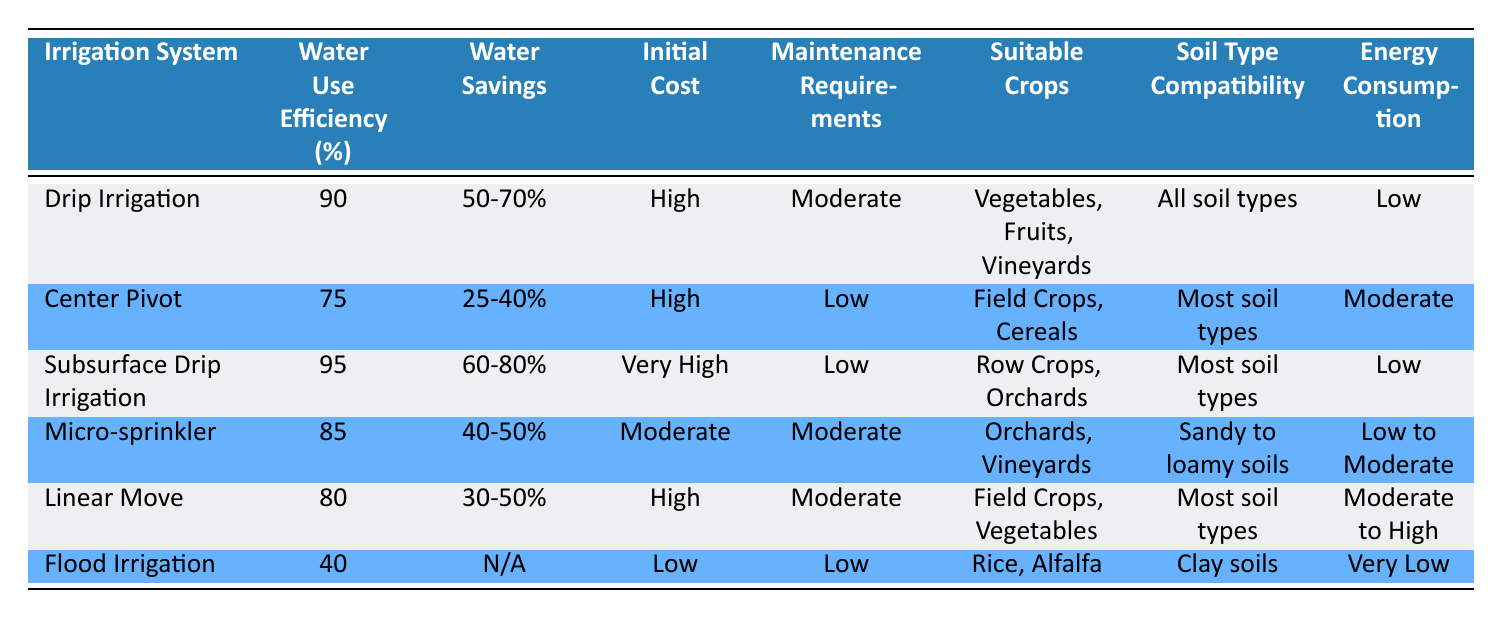What is the water use efficiency of Subsurface Drip Irrigation? The table directly provides the water use efficiency for Subsurface Drip Irrigation in the corresponding row. It is listed as 95%.
Answer: 95% Which irrigation system has the lowest initial cost? Looking at the initial cost column, Flood Irrigation is marked as Low, which is lower than all other systems listed.
Answer: Flood Irrigation True or False: Micro-sprinkler has a higher water savings percentage compared to Center Pivot. Micro-sprinkler shows water savings of 40-50%, while Center Pivot offers 25-40%. Since 40-50% is higher, the statement is true.
Answer: True What is the average water use efficiency of all irrigation systems listed? To find the average, we sum the water use efficiencies: 90 + 75 + 95 + 85 + 80 + 40 = 465. There are 6 systems, so the average is 465 / 6 = 77.5.
Answer: 77.5 Which irrigation system is suitable for sandy to loamy soils? The table shows that Micro-sprinkler is specifically compatible with sandy to loamy soils, as indicated in the Soil Type Compatibility column.
Answer: Micro-sprinkler How much more efficient is Subsurface Drip Irrigation compared to Flood Irrigation in terms of water use efficiency? Subsurface Drip Irrigation has an efficiency of 95%, and Flood Irrigation has 40%. The difference is 95 - 40 = 55.
Answer: 55 Is there any irrigation system listed that has low maintenance requirements? By examining the Maintenance Requirements column, both Center Pivot and Subsurface Drip Irrigation are marked with Low maintenance requirements, which indicates that there are systems with low maintenance.
Answer: Yes What is the energy consumption level of Linear Move irrigation system? The table indicates that the energy consumption for Linear Move is Moderate to High. This information is found in the corresponding row under Energy Consumption.
Answer: Moderate to High Which irrigation systems are suitable for field crops? From the Suitable Crops column, both Center Pivot and Linear Move are indicated as suitable for field crops. This can be identified by reading through their respective rows.
Answer: Center Pivot, Linear Move 